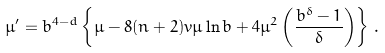<formula> <loc_0><loc_0><loc_500><loc_500>\mu ^ { \prime } = b ^ { 4 - d } \left \{ \mu - 8 ( n + 2 ) v \mu \ln b + 4 \mu ^ { 2 } \left ( \frac { b ^ { \delta } - 1 } { \delta } \right ) \right \} \, .</formula> 